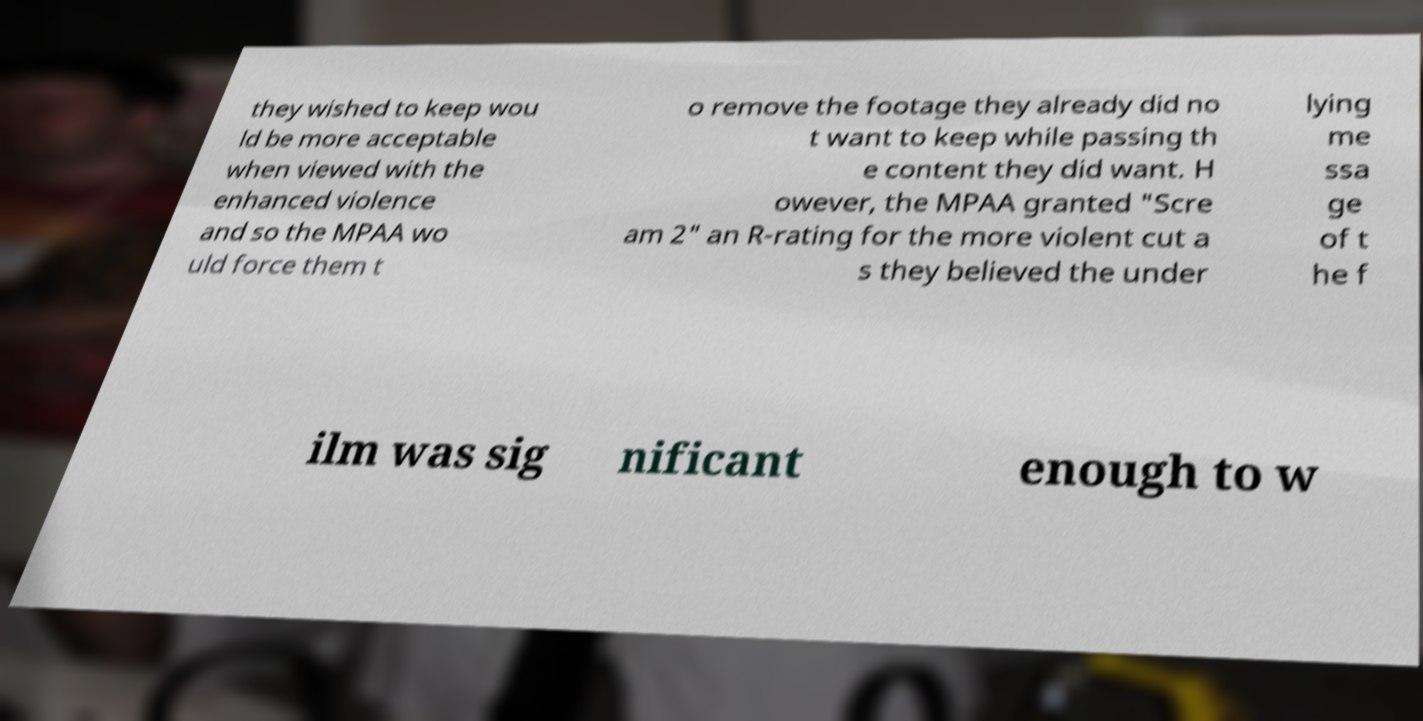For documentation purposes, I need the text within this image transcribed. Could you provide that? they wished to keep wou ld be more acceptable when viewed with the enhanced violence and so the MPAA wo uld force them t o remove the footage they already did no t want to keep while passing th e content they did want. H owever, the MPAA granted "Scre am 2" an R-rating for the more violent cut a s they believed the under lying me ssa ge of t he f ilm was sig nificant enough to w 